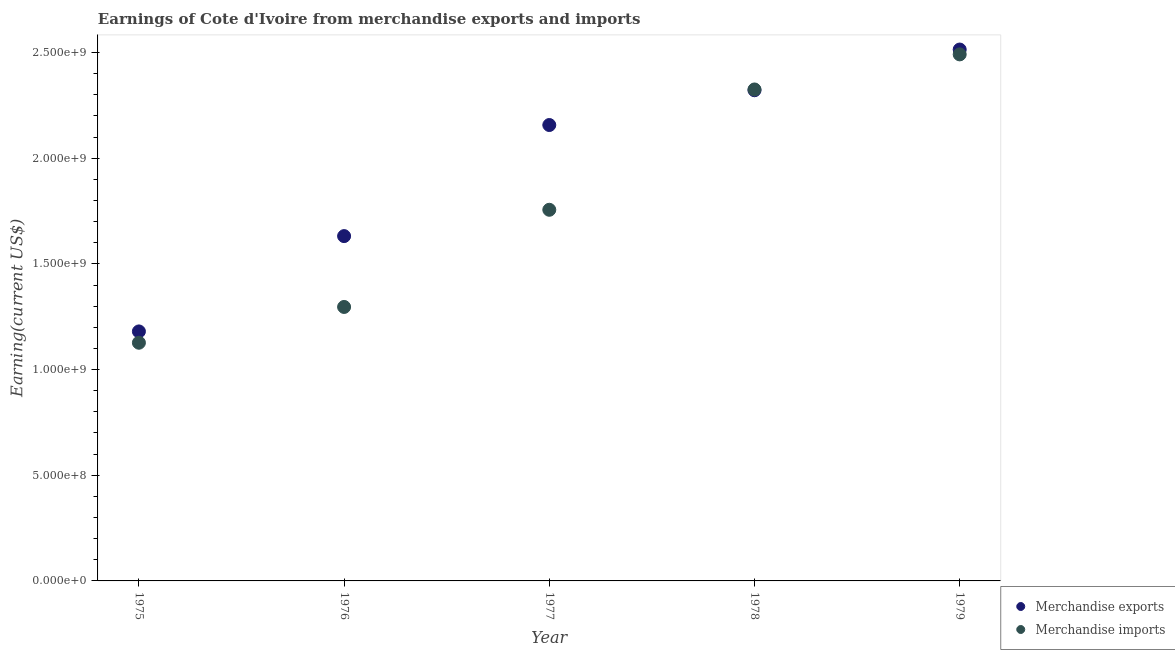How many different coloured dotlines are there?
Give a very brief answer. 2. What is the earnings from merchandise imports in 1975?
Give a very brief answer. 1.13e+09. Across all years, what is the maximum earnings from merchandise exports?
Give a very brief answer. 2.51e+09. Across all years, what is the minimum earnings from merchandise exports?
Offer a very short reply. 1.18e+09. In which year was the earnings from merchandise exports maximum?
Ensure brevity in your answer.  1979. In which year was the earnings from merchandise imports minimum?
Your answer should be very brief. 1975. What is the total earnings from merchandise imports in the graph?
Provide a succinct answer. 9.00e+09. What is the difference between the earnings from merchandise exports in 1976 and that in 1979?
Your answer should be very brief. -8.83e+08. What is the difference between the earnings from merchandise imports in 1979 and the earnings from merchandise exports in 1976?
Make the answer very short. 8.60e+08. What is the average earnings from merchandise exports per year?
Offer a terse response. 1.96e+09. In the year 1976, what is the difference between the earnings from merchandise exports and earnings from merchandise imports?
Your answer should be compact. 3.35e+08. In how many years, is the earnings from merchandise exports greater than 900000000 US$?
Your answer should be compact. 5. What is the ratio of the earnings from merchandise exports in 1978 to that in 1979?
Your answer should be very brief. 0.92. Is the difference between the earnings from merchandise exports in 1976 and 1978 greater than the difference between the earnings from merchandise imports in 1976 and 1978?
Provide a short and direct response. Yes. What is the difference between the highest and the second highest earnings from merchandise exports?
Your response must be concise. 1.93e+08. What is the difference between the highest and the lowest earnings from merchandise exports?
Your answer should be very brief. 1.33e+09. Does the earnings from merchandise exports monotonically increase over the years?
Provide a short and direct response. Yes. Is the earnings from merchandise exports strictly less than the earnings from merchandise imports over the years?
Keep it short and to the point. No. How many dotlines are there?
Provide a short and direct response. 2. What is the difference between two consecutive major ticks on the Y-axis?
Offer a very short reply. 5.00e+08. Are the values on the major ticks of Y-axis written in scientific E-notation?
Offer a terse response. Yes. Does the graph contain grids?
Offer a very short reply. No. How many legend labels are there?
Keep it short and to the point. 2. How are the legend labels stacked?
Keep it short and to the point. Vertical. What is the title of the graph?
Make the answer very short. Earnings of Cote d'Ivoire from merchandise exports and imports. What is the label or title of the X-axis?
Give a very brief answer. Year. What is the label or title of the Y-axis?
Provide a short and direct response. Earning(current US$). What is the Earning(current US$) in Merchandise exports in 1975?
Make the answer very short. 1.18e+09. What is the Earning(current US$) of Merchandise imports in 1975?
Provide a succinct answer. 1.13e+09. What is the Earning(current US$) of Merchandise exports in 1976?
Offer a terse response. 1.63e+09. What is the Earning(current US$) of Merchandise imports in 1976?
Provide a short and direct response. 1.30e+09. What is the Earning(current US$) in Merchandise exports in 1977?
Give a very brief answer. 2.16e+09. What is the Earning(current US$) of Merchandise imports in 1977?
Give a very brief answer. 1.76e+09. What is the Earning(current US$) in Merchandise exports in 1978?
Offer a very short reply. 2.32e+09. What is the Earning(current US$) of Merchandise imports in 1978?
Give a very brief answer. 2.33e+09. What is the Earning(current US$) in Merchandise exports in 1979?
Offer a very short reply. 2.51e+09. What is the Earning(current US$) in Merchandise imports in 1979?
Give a very brief answer. 2.49e+09. Across all years, what is the maximum Earning(current US$) of Merchandise exports?
Your response must be concise. 2.51e+09. Across all years, what is the maximum Earning(current US$) in Merchandise imports?
Provide a succinct answer. 2.49e+09. Across all years, what is the minimum Earning(current US$) of Merchandise exports?
Your response must be concise. 1.18e+09. Across all years, what is the minimum Earning(current US$) of Merchandise imports?
Offer a terse response. 1.13e+09. What is the total Earning(current US$) in Merchandise exports in the graph?
Your answer should be compact. 9.81e+09. What is the total Earning(current US$) in Merchandise imports in the graph?
Ensure brevity in your answer.  9.00e+09. What is the difference between the Earning(current US$) in Merchandise exports in 1975 and that in 1976?
Provide a succinct answer. -4.51e+08. What is the difference between the Earning(current US$) of Merchandise imports in 1975 and that in 1976?
Your answer should be very brief. -1.69e+08. What is the difference between the Earning(current US$) of Merchandise exports in 1975 and that in 1977?
Your response must be concise. -9.77e+08. What is the difference between the Earning(current US$) of Merchandise imports in 1975 and that in 1977?
Keep it short and to the point. -6.29e+08. What is the difference between the Earning(current US$) in Merchandise exports in 1975 and that in 1978?
Provide a succinct answer. -1.14e+09. What is the difference between the Earning(current US$) in Merchandise imports in 1975 and that in 1978?
Make the answer very short. -1.20e+09. What is the difference between the Earning(current US$) in Merchandise exports in 1975 and that in 1979?
Your answer should be compact. -1.33e+09. What is the difference between the Earning(current US$) in Merchandise imports in 1975 and that in 1979?
Your response must be concise. -1.36e+09. What is the difference between the Earning(current US$) of Merchandise exports in 1976 and that in 1977?
Your response must be concise. -5.26e+08. What is the difference between the Earning(current US$) of Merchandise imports in 1976 and that in 1977?
Make the answer very short. -4.60e+08. What is the difference between the Earning(current US$) of Merchandise exports in 1976 and that in 1978?
Give a very brief answer. -6.90e+08. What is the difference between the Earning(current US$) in Merchandise imports in 1976 and that in 1978?
Keep it short and to the point. -1.03e+09. What is the difference between the Earning(current US$) in Merchandise exports in 1976 and that in 1979?
Offer a terse response. -8.83e+08. What is the difference between the Earning(current US$) of Merchandise imports in 1976 and that in 1979?
Your answer should be very brief. -1.20e+09. What is the difference between the Earning(current US$) of Merchandise exports in 1977 and that in 1978?
Provide a short and direct response. -1.65e+08. What is the difference between the Earning(current US$) of Merchandise imports in 1977 and that in 1978?
Your answer should be very brief. -5.69e+08. What is the difference between the Earning(current US$) in Merchandise exports in 1977 and that in 1979?
Your response must be concise. -3.57e+08. What is the difference between the Earning(current US$) in Merchandise imports in 1977 and that in 1979?
Your answer should be very brief. -7.35e+08. What is the difference between the Earning(current US$) of Merchandise exports in 1978 and that in 1979?
Make the answer very short. -1.93e+08. What is the difference between the Earning(current US$) in Merchandise imports in 1978 and that in 1979?
Ensure brevity in your answer.  -1.66e+08. What is the difference between the Earning(current US$) of Merchandise exports in 1975 and the Earning(current US$) of Merchandise imports in 1976?
Provide a short and direct response. -1.16e+08. What is the difference between the Earning(current US$) of Merchandise exports in 1975 and the Earning(current US$) of Merchandise imports in 1977?
Your answer should be compact. -5.76e+08. What is the difference between the Earning(current US$) in Merchandise exports in 1975 and the Earning(current US$) in Merchandise imports in 1978?
Make the answer very short. -1.14e+09. What is the difference between the Earning(current US$) of Merchandise exports in 1975 and the Earning(current US$) of Merchandise imports in 1979?
Make the answer very short. -1.31e+09. What is the difference between the Earning(current US$) in Merchandise exports in 1976 and the Earning(current US$) in Merchandise imports in 1977?
Provide a succinct answer. -1.25e+08. What is the difference between the Earning(current US$) of Merchandise exports in 1976 and the Earning(current US$) of Merchandise imports in 1978?
Ensure brevity in your answer.  -6.94e+08. What is the difference between the Earning(current US$) of Merchandise exports in 1976 and the Earning(current US$) of Merchandise imports in 1979?
Provide a short and direct response. -8.60e+08. What is the difference between the Earning(current US$) in Merchandise exports in 1977 and the Earning(current US$) in Merchandise imports in 1978?
Your answer should be compact. -1.68e+08. What is the difference between the Earning(current US$) of Merchandise exports in 1977 and the Earning(current US$) of Merchandise imports in 1979?
Your answer should be compact. -3.34e+08. What is the difference between the Earning(current US$) of Merchandise exports in 1978 and the Earning(current US$) of Merchandise imports in 1979?
Provide a short and direct response. -1.70e+08. What is the average Earning(current US$) of Merchandise exports per year?
Your answer should be compact. 1.96e+09. What is the average Earning(current US$) of Merchandise imports per year?
Your answer should be compact. 1.80e+09. In the year 1975, what is the difference between the Earning(current US$) of Merchandise exports and Earning(current US$) of Merchandise imports?
Your response must be concise. 5.36e+07. In the year 1976, what is the difference between the Earning(current US$) in Merchandise exports and Earning(current US$) in Merchandise imports?
Provide a short and direct response. 3.35e+08. In the year 1977, what is the difference between the Earning(current US$) of Merchandise exports and Earning(current US$) of Merchandise imports?
Your answer should be very brief. 4.01e+08. In the year 1978, what is the difference between the Earning(current US$) in Merchandise exports and Earning(current US$) in Merchandise imports?
Make the answer very short. -3.70e+06. In the year 1979, what is the difference between the Earning(current US$) in Merchandise exports and Earning(current US$) in Merchandise imports?
Offer a terse response. 2.30e+07. What is the ratio of the Earning(current US$) in Merchandise exports in 1975 to that in 1976?
Keep it short and to the point. 0.72. What is the ratio of the Earning(current US$) of Merchandise imports in 1975 to that in 1976?
Your answer should be compact. 0.87. What is the ratio of the Earning(current US$) of Merchandise exports in 1975 to that in 1977?
Your answer should be compact. 0.55. What is the ratio of the Earning(current US$) of Merchandise imports in 1975 to that in 1977?
Keep it short and to the point. 0.64. What is the ratio of the Earning(current US$) in Merchandise exports in 1975 to that in 1978?
Keep it short and to the point. 0.51. What is the ratio of the Earning(current US$) of Merchandise imports in 1975 to that in 1978?
Offer a very short reply. 0.48. What is the ratio of the Earning(current US$) of Merchandise exports in 1975 to that in 1979?
Your response must be concise. 0.47. What is the ratio of the Earning(current US$) in Merchandise imports in 1975 to that in 1979?
Your answer should be compact. 0.45. What is the ratio of the Earning(current US$) of Merchandise exports in 1976 to that in 1977?
Make the answer very short. 0.76. What is the ratio of the Earning(current US$) of Merchandise imports in 1976 to that in 1977?
Ensure brevity in your answer.  0.74. What is the ratio of the Earning(current US$) in Merchandise exports in 1976 to that in 1978?
Your answer should be compact. 0.7. What is the ratio of the Earning(current US$) in Merchandise imports in 1976 to that in 1978?
Give a very brief answer. 0.56. What is the ratio of the Earning(current US$) in Merchandise exports in 1976 to that in 1979?
Your response must be concise. 0.65. What is the ratio of the Earning(current US$) of Merchandise imports in 1976 to that in 1979?
Your answer should be very brief. 0.52. What is the ratio of the Earning(current US$) of Merchandise exports in 1977 to that in 1978?
Ensure brevity in your answer.  0.93. What is the ratio of the Earning(current US$) in Merchandise imports in 1977 to that in 1978?
Your answer should be compact. 0.76. What is the ratio of the Earning(current US$) of Merchandise exports in 1977 to that in 1979?
Your answer should be compact. 0.86. What is the ratio of the Earning(current US$) of Merchandise imports in 1977 to that in 1979?
Keep it short and to the point. 0.7. What is the ratio of the Earning(current US$) in Merchandise exports in 1978 to that in 1979?
Your answer should be compact. 0.92. What is the ratio of the Earning(current US$) in Merchandise imports in 1978 to that in 1979?
Keep it short and to the point. 0.93. What is the difference between the highest and the second highest Earning(current US$) of Merchandise exports?
Your answer should be very brief. 1.93e+08. What is the difference between the highest and the second highest Earning(current US$) of Merchandise imports?
Your response must be concise. 1.66e+08. What is the difference between the highest and the lowest Earning(current US$) in Merchandise exports?
Make the answer very short. 1.33e+09. What is the difference between the highest and the lowest Earning(current US$) of Merchandise imports?
Keep it short and to the point. 1.36e+09. 